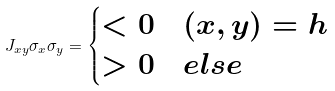<formula> <loc_0><loc_0><loc_500><loc_500>J _ { x y } \sigma _ { x } \sigma _ { y } = \begin{cases} < 0 & ( x , y ) = h \\ > 0 & e l s e \end{cases}</formula> 